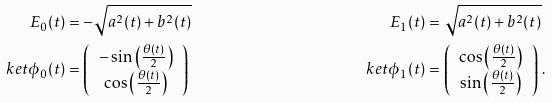Convert formula to latex. <formula><loc_0><loc_0><loc_500><loc_500>E _ { 0 } ( t ) & = - \sqrt { a ^ { 2 } ( t ) + b ^ { 2 } ( t ) } & E _ { 1 } ( t ) & = \sqrt { a ^ { 2 } ( t ) + b ^ { 2 } ( t ) } \\ \ k e t { \phi _ { 0 } ( t ) } & = \left ( \begin{array} { c } - \sin \left ( \frac { \theta ( t ) } { 2 } \right ) \\ \cos \left ( \frac { \theta ( t ) } { 2 } \right ) \end{array} \right ) & \ k e t { \phi _ { 1 } ( t ) } & = \left ( \begin{array} { c } \cos \left ( \frac { \theta ( t ) } { 2 } \right ) \\ \sin \left ( \frac { \theta ( t ) } { 2 } \right ) \end{array} \right ) \, .</formula> 